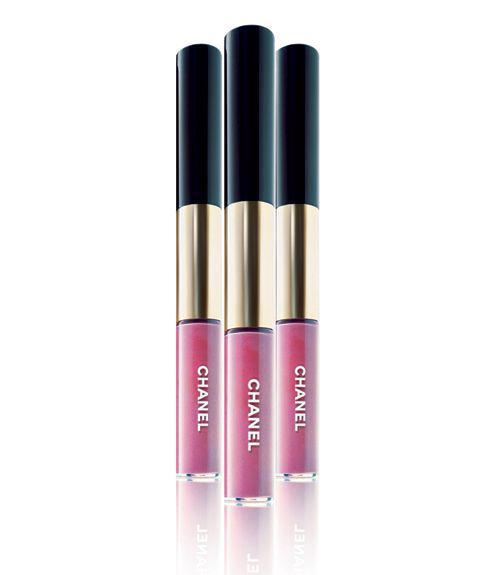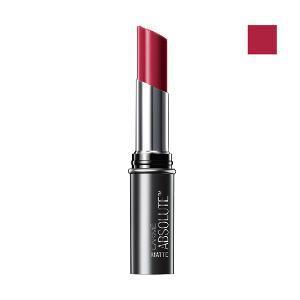The first image is the image on the left, the second image is the image on the right. For the images shown, is this caption "The five black caps of the makeup in the image on the right are fully visible." true? Answer yes or no. No. The first image is the image on the left, the second image is the image on the right. Evaluate the accuracy of this statement regarding the images: "One image shows a lip makeup with its cover off.". Is it true? Answer yes or no. Yes. 